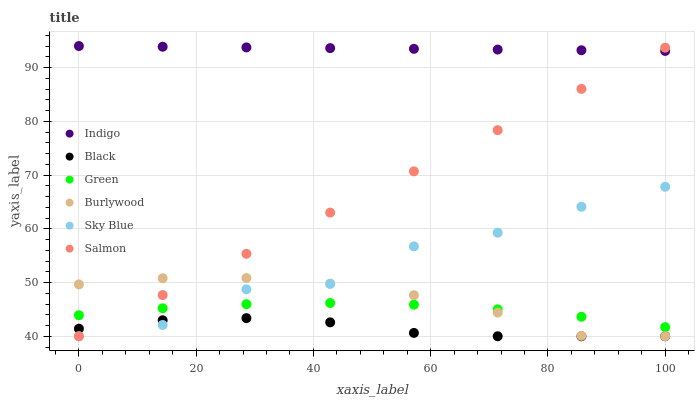Does Black have the minimum area under the curve?
Answer yes or no. Yes. Does Indigo have the maximum area under the curve?
Answer yes or no. Yes. Does Burlywood have the minimum area under the curve?
Answer yes or no. No. Does Burlywood have the maximum area under the curve?
Answer yes or no. No. Is Salmon the smoothest?
Answer yes or no. Yes. Is Sky Blue the roughest?
Answer yes or no. Yes. Is Burlywood the smoothest?
Answer yes or no. No. Is Burlywood the roughest?
Answer yes or no. No. Does Burlywood have the lowest value?
Answer yes or no. Yes. Does Green have the lowest value?
Answer yes or no. No. Does Indigo have the highest value?
Answer yes or no. Yes. Does Burlywood have the highest value?
Answer yes or no. No. Is Black less than Green?
Answer yes or no. Yes. Is Indigo greater than Black?
Answer yes or no. Yes. Does Sky Blue intersect Salmon?
Answer yes or no. Yes. Is Sky Blue less than Salmon?
Answer yes or no. No. Is Sky Blue greater than Salmon?
Answer yes or no. No. Does Black intersect Green?
Answer yes or no. No. 